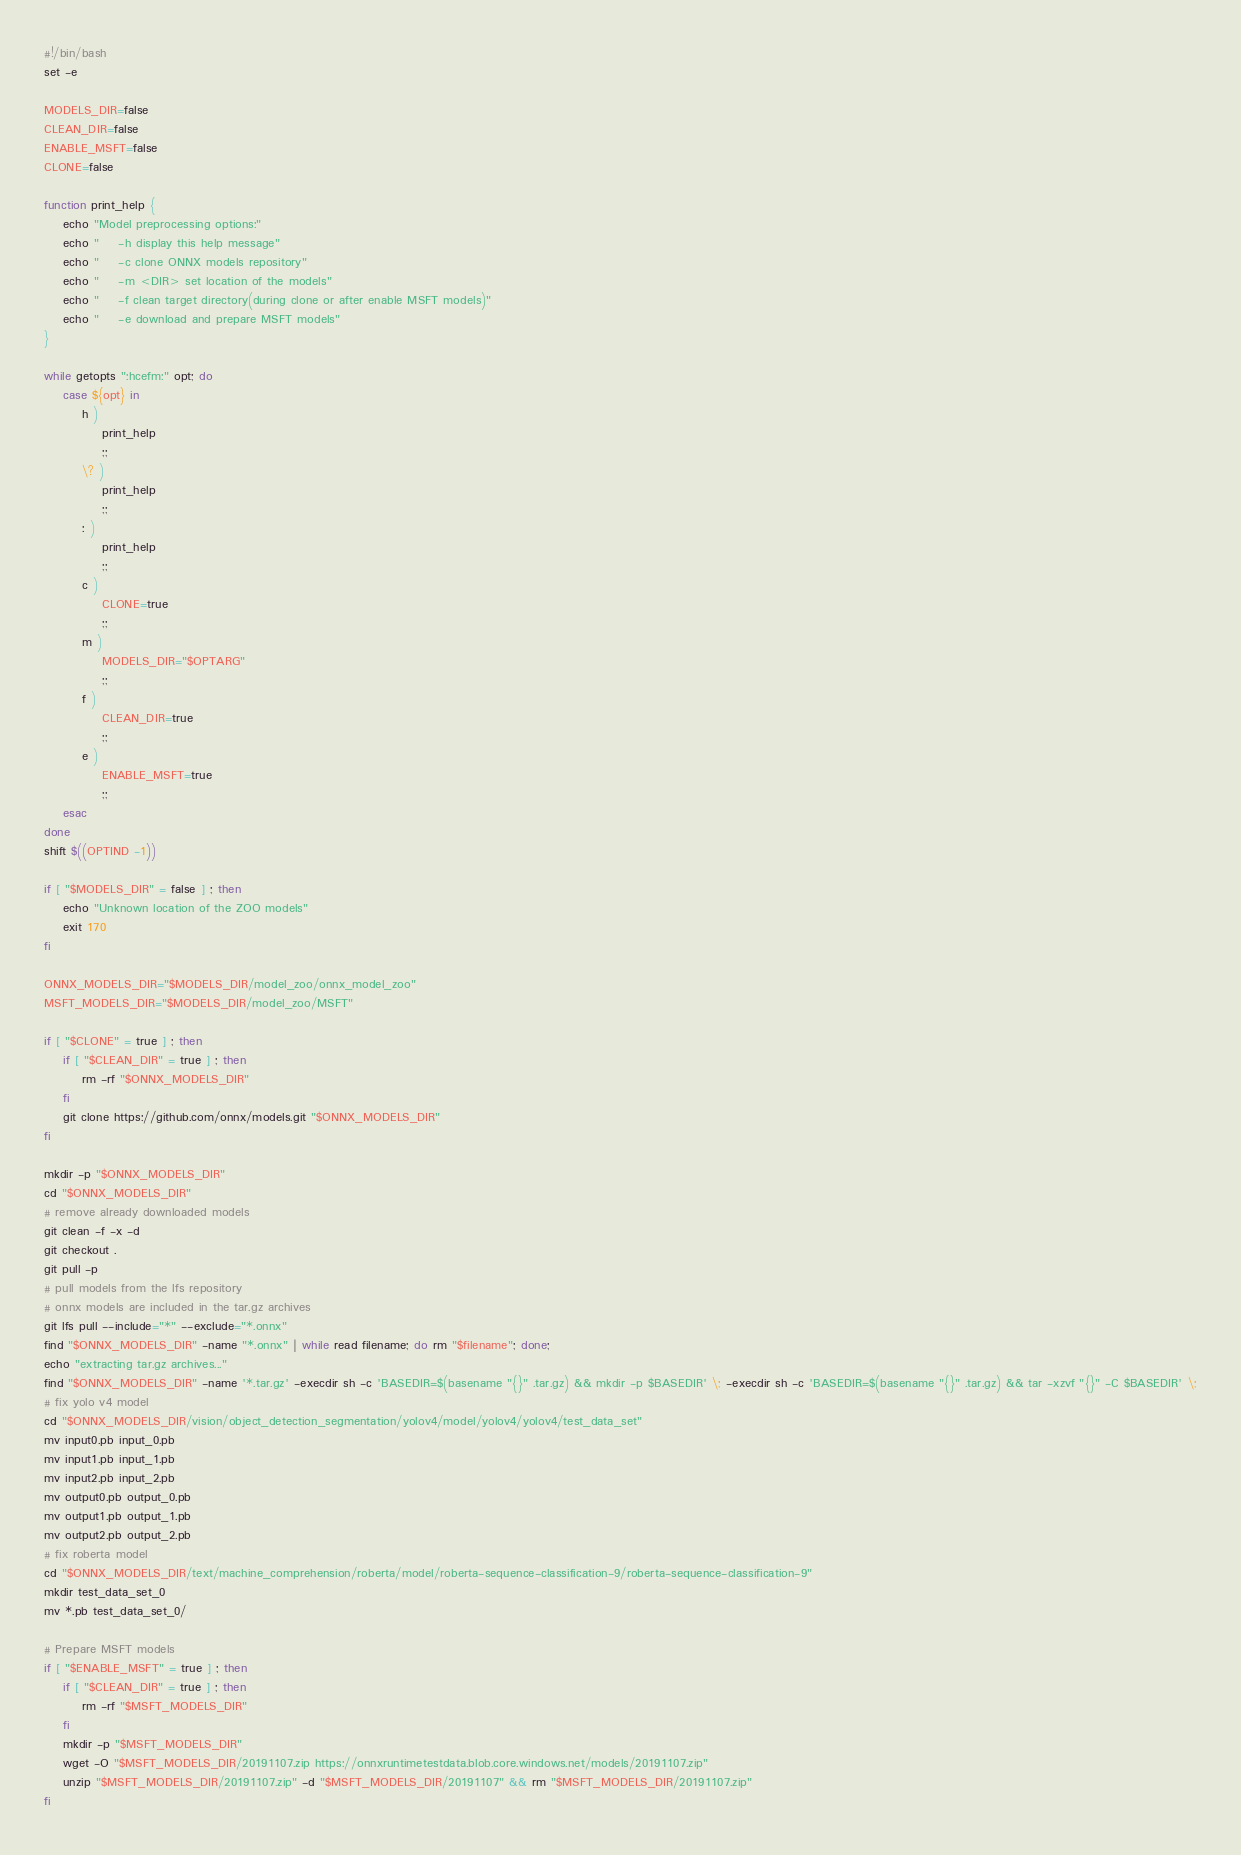<code> <loc_0><loc_0><loc_500><loc_500><_Bash_>#!/bin/bash
set -e

MODELS_DIR=false
CLEAN_DIR=false
ENABLE_MSFT=false
CLONE=false

function print_help {
    echo "Model preprocessing options:"
    echo "    -h display this help message"
    echo "    -c clone ONNX models repository"
    echo "    -m <DIR> set location of the models"
    echo "    -f clean target directory(during clone or after enable MSFT models)"
    echo "    -e download and prepare MSFT models"
}

while getopts ":hcefm:" opt; do
    case ${opt} in
        h )
            print_help
            ;;
        \? )
            print_help
            ;;
        : )
            print_help
            ;;
        c )
            CLONE=true
            ;;
        m )
            MODELS_DIR="$OPTARG"
            ;;
        f )
            CLEAN_DIR=true
            ;;
        e )
            ENABLE_MSFT=true
            ;;
    esac
done
shift $((OPTIND -1))

if [ "$MODELS_DIR" = false ] ; then
    echo "Unknown location of the ZOO models"
    exit 170
fi

ONNX_MODELS_DIR="$MODELS_DIR/model_zoo/onnx_model_zoo"
MSFT_MODELS_DIR="$MODELS_DIR/model_zoo/MSFT"

if [ "$CLONE" = true ] ; then
    if [ "$CLEAN_DIR" = true ] ; then
        rm -rf "$ONNX_MODELS_DIR"
    fi
    git clone https://github.com/onnx/models.git "$ONNX_MODELS_DIR"
fi

mkdir -p "$ONNX_MODELS_DIR"
cd "$ONNX_MODELS_DIR"
# remove already downloaded models
git clean -f -x -d
git checkout .
git pull -p
# pull models from the lfs repository
# onnx models are included in the tar.gz archives
git lfs pull --include="*" --exclude="*.onnx"
find "$ONNX_MODELS_DIR" -name "*.onnx" | while read filename; do rm "$filename"; done;
echo "extracting tar.gz archives..."
find "$ONNX_MODELS_DIR" -name '*.tar.gz' -execdir sh -c 'BASEDIR=$(basename "{}" .tar.gz) && mkdir -p $BASEDIR' \; -execdir sh -c 'BASEDIR=$(basename "{}" .tar.gz) && tar -xzvf "{}" -C $BASEDIR' \;
# fix yolo v4 model
cd "$ONNX_MODELS_DIR/vision/object_detection_segmentation/yolov4/model/yolov4/yolov4/test_data_set"
mv input0.pb input_0.pb
mv input1.pb input_1.pb
mv input2.pb input_2.pb
mv output0.pb output_0.pb
mv output1.pb output_1.pb
mv output2.pb output_2.pb
# fix roberta model
cd "$ONNX_MODELS_DIR/text/machine_comprehension/roberta/model/roberta-sequence-classification-9/roberta-sequence-classification-9"
mkdir test_data_set_0
mv *.pb test_data_set_0/

# Prepare MSFT models
if [ "$ENABLE_MSFT" = true ] ; then
    if [ "$CLEAN_DIR" = true ] ; then
        rm -rf "$MSFT_MODELS_DIR"
    fi
    mkdir -p "$MSFT_MODELS_DIR"
    wget -O "$MSFT_MODELS_DIR/20191107.zip https://onnxruntimetestdata.blob.core.windows.net/models/20191107.zip"
    unzip "$MSFT_MODELS_DIR/20191107.zip" -d "$MSFT_MODELS_DIR/20191107" && rm "$MSFT_MODELS_DIR/20191107.zip"
fi
</code> 